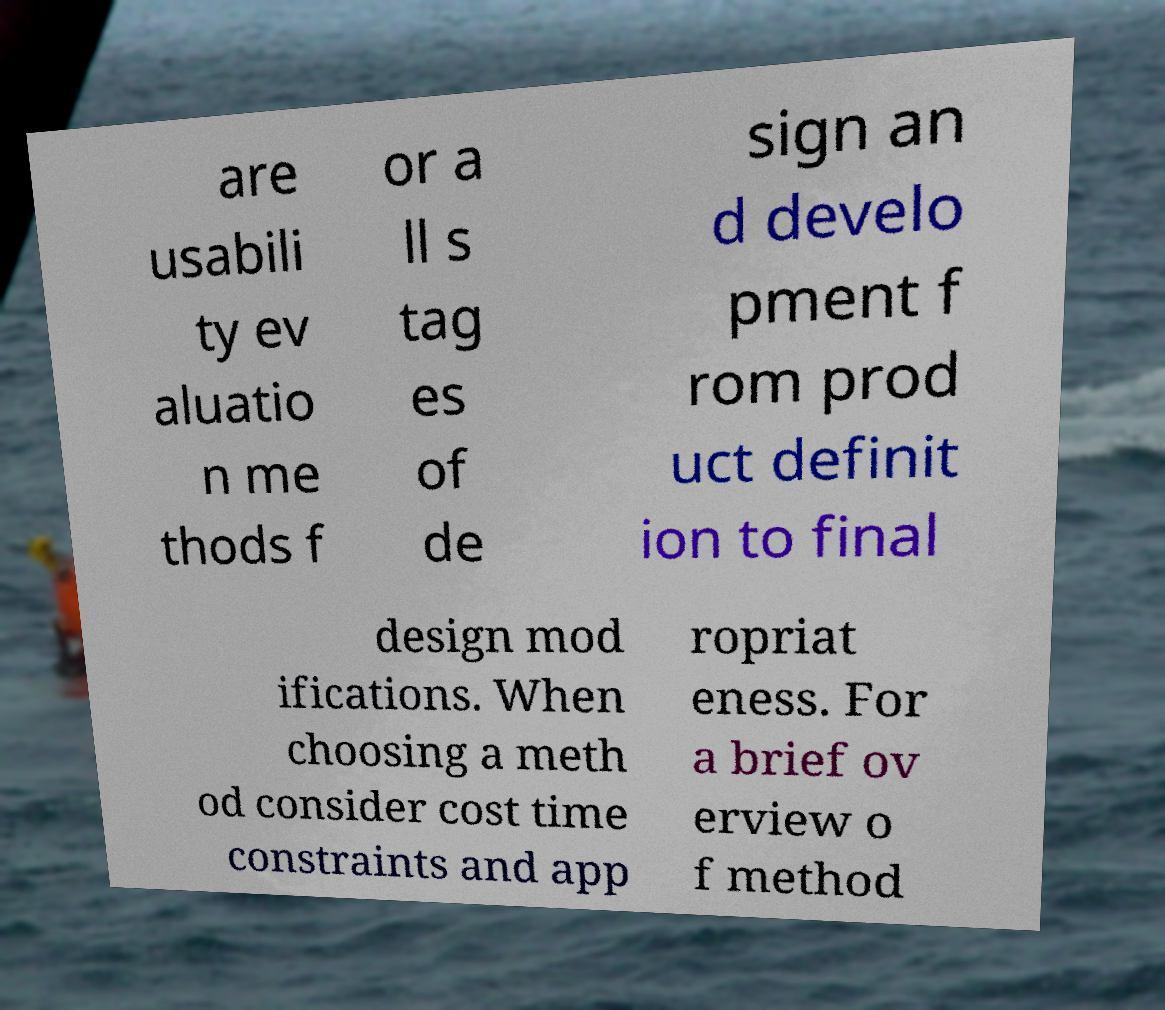I need the written content from this picture converted into text. Can you do that? are usabili ty ev aluatio n me thods f or a ll s tag es of de sign an d develo pment f rom prod uct definit ion to final design mod ifications. When choosing a meth od consider cost time constraints and app ropriat eness. For a brief ov erview o f method 